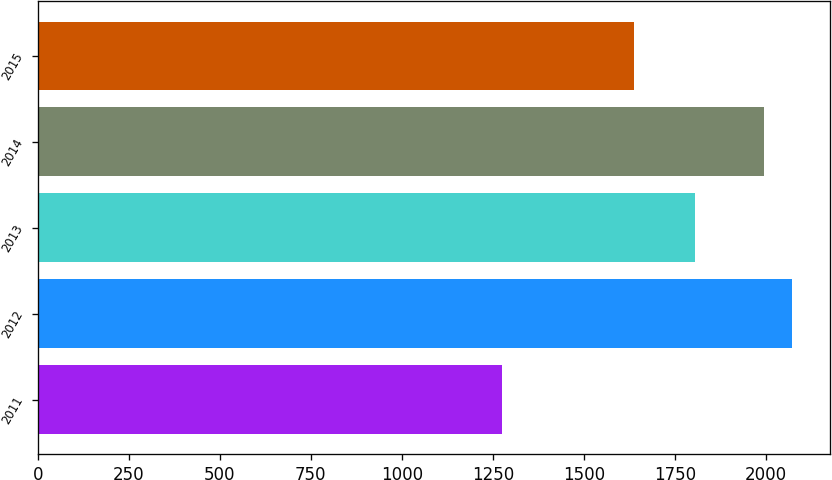Convert chart to OTSL. <chart><loc_0><loc_0><loc_500><loc_500><bar_chart><fcel>2011<fcel>2012<fcel>2013<fcel>2014<fcel>2015<nl><fcel>1276<fcel>2071.1<fcel>1804<fcel>1993<fcel>1636<nl></chart> 